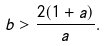Convert formula to latex. <formula><loc_0><loc_0><loc_500><loc_500>b > \frac { 2 ( 1 + a ) } { a } .</formula> 